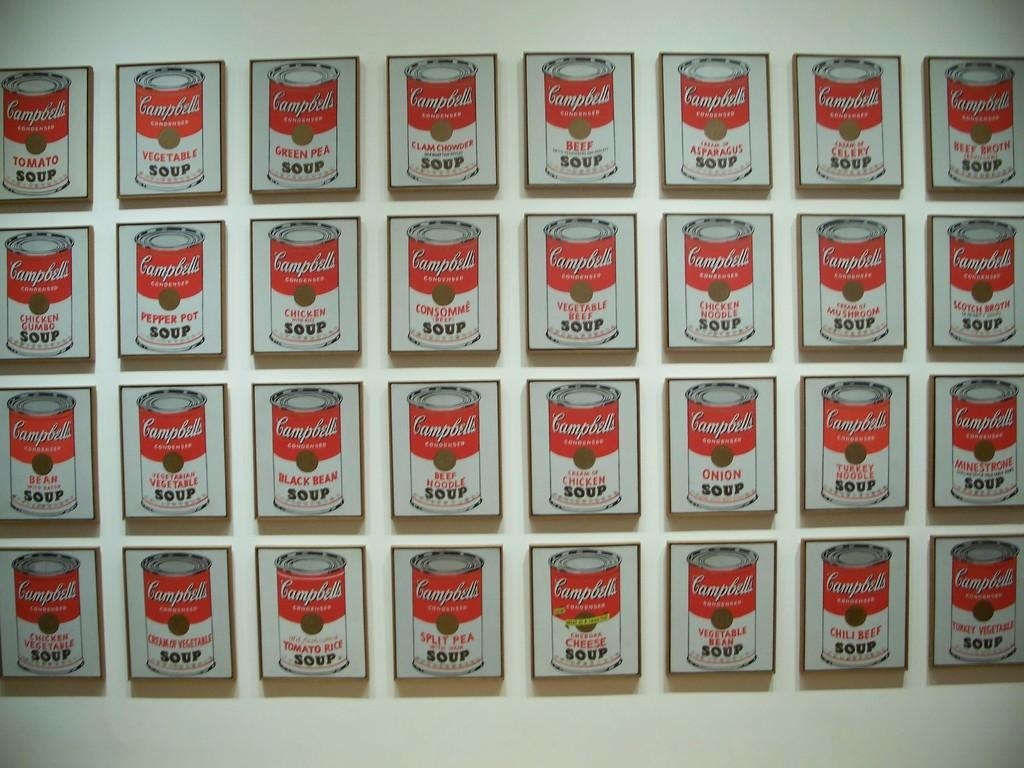<image>
Describe the image concisely. Images of cans of soup in different flavors are displayed on a wall. 